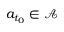<formula> <loc_0><loc_0><loc_500><loc_500>a _ { t _ { 0 } } \in \mathcal { A }</formula> 